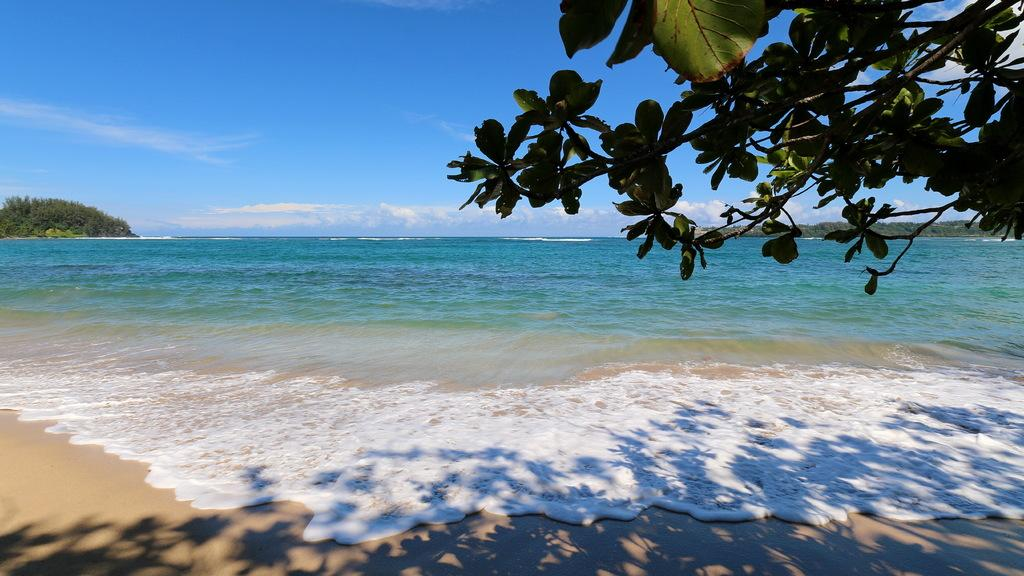What type of location is depicted in the image? There is a beach in the image. What can be seen on the left side of the image? There are trees on the left side of the image. Where are the branches of a tree located in the image? The branches of a tree are in the right top corner of the image. What type of organization is hosting a feast on the beach in the image? There is no organization or feast present in the image; it only shows a beach with trees and branches. 